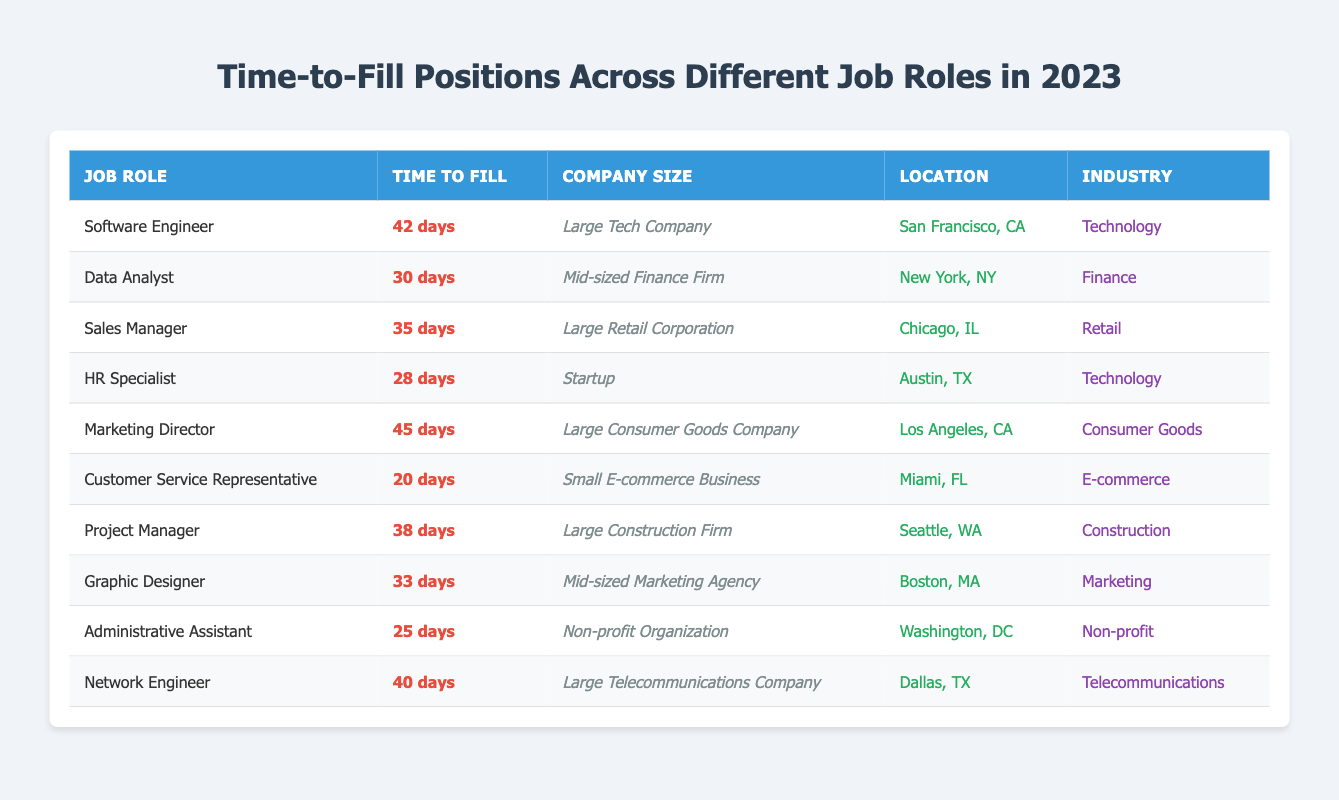What is the time to fill for the HR Specialist role? The table provides specific values for each job role, and for the HR Specialist role, it states that the time to fill is 28 days.
Answer: 28 days Which job role has the longest time to fill? Looking through the "Time to Fill" column in the table, "Marketing Director" has the highest value at 45 days.
Answer: Marketing Director What is the average time to fill for all job roles listed in the table? To find the average, we sum all the time to fill values: 42 + 30 + 35 + 28 + 45 + 20 + 38 + 33 + 25 + 40 = 366 days. Then, there are 10 job roles, so the average is 366/10 = 36.6 days.
Answer: 36.6 days Is the time to fill for the Data Analyst role less than 35 days? By checking the "Time to Fill" for the Data Analyst, which is 30 days, we can confirm that 30 days is indeed less than 35 days.
Answer: Yes How many days does it take to fill a Customer Service Representative position compared to a Network Engineer position? The Customer Service Representative takes 20 days and the Network Engineer takes 40 days. The difference is 40 - 20 = 20 days.
Answer: 20 days Which location has the shortest time to fill for a job? The table indicates that the Customer Service Representative role in Miami, FL has the shortest time to fill at 20 days.
Answer: Miami, FL Is there any job role in the e-commerce industry that has a time to fill over 25 days? The only e-commerce role listed is Customer Service Representative, which has a time to fill of 20 days, confirming there are no roles over 25 days in this industry.
Answer: No What is the total time to fill for all roles in the Technology industry? The Technology industry has two roles: Software Engineer (42 days) and HR Specialist (28 days). Adding these gives: 42 + 28 = 70 days.
Answer: 70 days Which job role from a startup has the shortest time to fill? The table lists HR Specialist as the only role from a startup, with a time to fill of 28 days, making it the only one.
Answer: HR Specialist Which job role has a time to fill that is exactly 35 days? The Sales Manager role has a time to fill of 35 days as stated in the table.
Answer: Sales Manager 